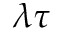<formula> <loc_0><loc_0><loc_500><loc_500>\lambda \tau</formula> 